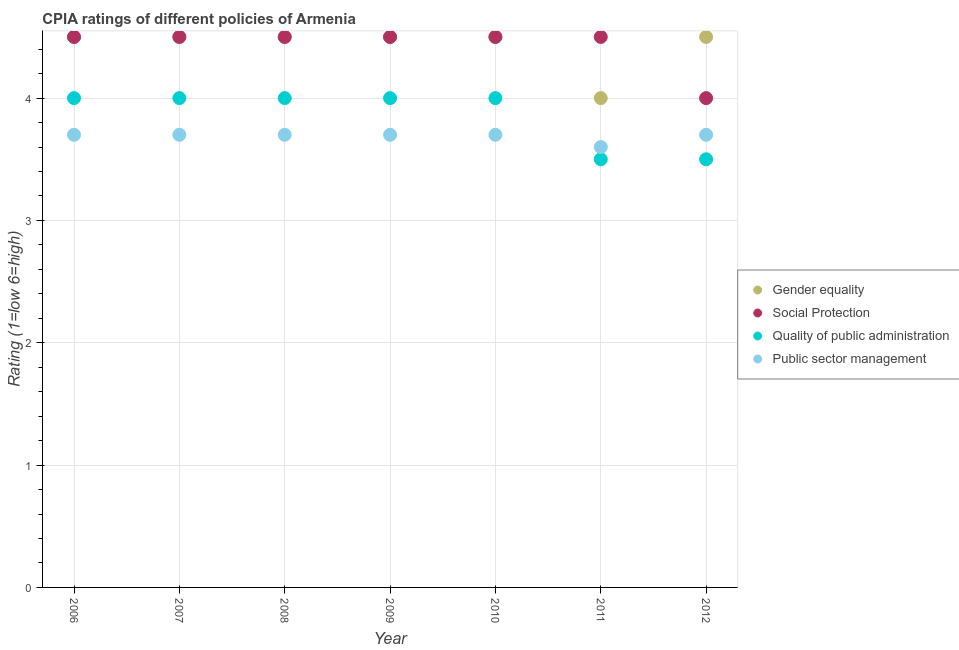Is the number of dotlines equal to the number of legend labels?
Make the answer very short. Yes. What is the cpia rating of gender equality in 2010?
Give a very brief answer. 4.5. In which year was the cpia rating of gender equality maximum?
Your answer should be very brief. 2006. In which year was the cpia rating of gender equality minimum?
Make the answer very short. 2011. What is the difference between the cpia rating of quality of public administration in 2010 and that in 2012?
Offer a terse response. 0.5. What is the difference between the cpia rating of public sector management in 2007 and the cpia rating of social protection in 2009?
Provide a succinct answer. -0.8. What is the average cpia rating of social protection per year?
Give a very brief answer. 4.43. In the year 2012, what is the difference between the cpia rating of quality of public administration and cpia rating of public sector management?
Your response must be concise. -0.2. In how many years, is the cpia rating of quality of public administration greater than 1.6?
Offer a very short reply. 7. Is the difference between the cpia rating of gender equality in 2006 and 2009 greater than the difference between the cpia rating of quality of public administration in 2006 and 2009?
Your answer should be very brief. No. What is the difference between the highest and the second highest cpia rating of social protection?
Your answer should be very brief. 0. What is the difference between the highest and the lowest cpia rating of gender equality?
Ensure brevity in your answer.  0.5. Is the sum of the cpia rating of public sector management in 2007 and 2012 greater than the maximum cpia rating of gender equality across all years?
Offer a terse response. Yes. Is it the case that in every year, the sum of the cpia rating of gender equality and cpia rating of social protection is greater than the cpia rating of quality of public administration?
Provide a succinct answer. Yes. Does the cpia rating of public sector management monotonically increase over the years?
Make the answer very short. No. Is the cpia rating of gender equality strictly greater than the cpia rating of public sector management over the years?
Provide a short and direct response. Yes. Is the cpia rating of public sector management strictly less than the cpia rating of gender equality over the years?
Provide a short and direct response. Yes. How many dotlines are there?
Keep it short and to the point. 4. What is the difference between two consecutive major ticks on the Y-axis?
Offer a very short reply. 1. Are the values on the major ticks of Y-axis written in scientific E-notation?
Provide a succinct answer. No. Does the graph contain any zero values?
Provide a succinct answer. No. Where does the legend appear in the graph?
Your answer should be compact. Center right. How many legend labels are there?
Ensure brevity in your answer.  4. How are the legend labels stacked?
Keep it short and to the point. Vertical. What is the title of the graph?
Your answer should be compact. CPIA ratings of different policies of Armenia. What is the label or title of the X-axis?
Offer a very short reply. Year. What is the label or title of the Y-axis?
Make the answer very short. Rating (1=low 6=high). What is the Rating (1=low 6=high) in Gender equality in 2006?
Ensure brevity in your answer.  4.5. What is the Rating (1=low 6=high) in Social Protection in 2006?
Provide a short and direct response. 4.5. What is the Rating (1=low 6=high) in Quality of public administration in 2006?
Keep it short and to the point. 4. What is the Rating (1=low 6=high) in Public sector management in 2006?
Provide a succinct answer. 3.7. What is the Rating (1=low 6=high) of Public sector management in 2007?
Provide a succinct answer. 3.7. What is the Rating (1=low 6=high) in Social Protection in 2008?
Your response must be concise. 4.5. What is the Rating (1=low 6=high) in Quality of public administration in 2008?
Your response must be concise. 4. What is the Rating (1=low 6=high) in Quality of public administration in 2009?
Your answer should be very brief. 4. What is the Rating (1=low 6=high) of Public sector management in 2009?
Provide a short and direct response. 3.7. What is the Rating (1=low 6=high) in Social Protection in 2010?
Offer a very short reply. 4.5. What is the Rating (1=low 6=high) of Gender equality in 2011?
Your response must be concise. 4. What is the Rating (1=low 6=high) of Quality of public administration in 2011?
Give a very brief answer. 3.5. What is the Rating (1=low 6=high) of Public sector management in 2011?
Offer a terse response. 3.6. What is the Rating (1=low 6=high) of Gender equality in 2012?
Give a very brief answer. 4.5. What is the Rating (1=low 6=high) in Social Protection in 2012?
Ensure brevity in your answer.  4. What is the Rating (1=low 6=high) in Public sector management in 2012?
Offer a terse response. 3.7. Across all years, what is the maximum Rating (1=low 6=high) of Quality of public administration?
Offer a very short reply. 4. Across all years, what is the minimum Rating (1=low 6=high) of Gender equality?
Provide a succinct answer. 4. Across all years, what is the minimum Rating (1=low 6=high) in Quality of public administration?
Your answer should be compact. 3.5. What is the total Rating (1=low 6=high) of Quality of public administration in the graph?
Your answer should be very brief. 27. What is the total Rating (1=low 6=high) of Public sector management in the graph?
Offer a terse response. 25.8. What is the difference between the Rating (1=low 6=high) in Gender equality in 2006 and that in 2007?
Make the answer very short. 0. What is the difference between the Rating (1=low 6=high) of Social Protection in 2006 and that in 2007?
Make the answer very short. 0. What is the difference between the Rating (1=low 6=high) in Public sector management in 2006 and that in 2007?
Make the answer very short. 0. What is the difference between the Rating (1=low 6=high) of Gender equality in 2006 and that in 2008?
Ensure brevity in your answer.  0. What is the difference between the Rating (1=low 6=high) of Quality of public administration in 2006 and that in 2008?
Ensure brevity in your answer.  0. What is the difference between the Rating (1=low 6=high) of Public sector management in 2006 and that in 2008?
Provide a short and direct response. 0. What is the difference between the Rating (1=low 6=high) in Public sector management in 2006 and that in 2009?
Ensure brevity in your answer.  0. What is the difference between the Rating (1=low 6=high) of Gender equality in 2006 and that in 2010?
Your response must be concise. 0. What is the difference between the Rating (1=low 6=high) of Social Protection in 2006 and that in 2010?
Provide a succinct answer. 0. What is the difference between the Rating (1=low 6=high) in Public sector management in 2006 and that in 2010?
Give a very brief answer. 0. What is the difference between the Rating (1=low 6=high) in Social Protection in 2006 and that in 2011?
Make the answer very short. 0. What is the difference between the Rating (1=low 6=high) in Quality of public administration in 2006 and that in 2011?
Offer a terse response. 0.5. What is the difference between the Rating (1=low 6=high) of Public sector management in 2006 and that in 2011?
Provide a succinct answer. 0.1. What is the difference between the Rating (1=low 6=high) in Social Protection in 2006 and that in 2012?
Your answer should be very brief. 0.5. What is the difference between the Rating (1=low 6=high) of Quality of public administration in 2006 and that in 2012?
Your answer should be compact. 0.5. What is the difference between the Rating (1=low 6=high) in Social Protection in 2007 and that in 2008?
Your answer should be compact. 0. What is the difference between the Rating (1=low 6=high) in Public sector management in 2007 and that in 2008?
Make the answer very short. 0. What is the difference between the Rating (1=low 6=high) in Gender equality in 2007 and that in 2009?
Your answer should be very brief. 0. What is the difference between the Rating (1=low 6=high) in Public sector management in 2007 and that in 2009?
Your answer should be compact. 0. What is the difference between the Rating (1=low 6=high) in Public sector management in 2007 and that in 2010?
Your answer should be compact. 0. What is the difference between the Rating (1=low 6=high) in Social Protection in 2007 and that in 2011?
Keep it short and to the point. 0. What is the difference between the Rating (1=low 6=high) of Public sector management in 2007 and that in 2011?
Your answer should be very brief. 0.1. What is the difference between the Rating (1=low 6=high) in Social Protection in 2007 and that in 2012?
Your answer should be compact. 0.5. What is the difference between the Rating (1=low 6=high) in Public sector management in 2007 and that in 2012?
Provide a succinct answer. 0. What is the difference between the Rating (1=low 6=high) in Quality of public administration in 2008 and that in 2009?
Offer a very short reply. 0. What is the difference between the Rating (1=low 6=high) of Public sector management in 2008 and that in 2009?
Ensure brevity in your answer.  0. What is the difference between the Rating (1=low 6=high) of Gender equality in 2008 and that in 2011?
Offer a very short reply. 0.5. What is the difference between the Rating (1=low 6=high) in Quality of public administration in 2008 and that in 2011?
Provide a succinct answer. 0.5. What is the difference between the Rating (1=low 6=high) in Gender equality in 2008 and that in 2012?
Your answer should be compact. 0. What is the difference between the Rating (1=low 6=high) in Social Protection in 2008 and that in 2012?
Your answer should be very brief. 0.5. What is the difference between the Rating (1=low 6=high) of Public sector management in 2008 and that in 2012?
Your answer should be very brief. 0. What is the difference between the Rating (1=low 6=high) in Gender equality in 2009 and that in 2010?
Provide a succinct answer. 0. What is the difference between the Rating (1=low 6=high) of Public sector management in 2009 and that in 2010?
Give a very brief answer. 0. What is the difference between the Rating (1=low 6=high) in Gender equality in 2009 and that in 2011?
Keep it short and to the point. 0.5. What is the difference between the Rating (1=low 6=high) in Public sector management in 2009 and that in 2011?
Offer a terse response. 0.1. What is the difference between the Rating (1=low 6=high) of Quality of public administration in 2010 and that in 2011?
Keep it short and to the point. 0.5. What is the difference between the Rating (1=low 6=high) of Social Protection in 2010 and that in 2012?
Your response must be concise. 0.5. What is the difference between the Rating (1=low 6=high) in Social Protection in 2011 and that in 2012?
Your answer should be compact. 0.5. What is the difference between the Rating (1=low 6=high) in Public sector management in 2011 and that in 2012?
Provide a succinct answer. -0.1. What is the difference between the Rating (1=low 6=high) in Social Protection in 2006 and the Rating (1=low 6=high) in Public sector management in 2007?
Give a very brief answer. 0.8. What is the difference between the Rating (1=low 6=high) of Gender equality in 2006 and the Rating (1=low 6=high) of Social Protection in 2008?
Give a very brief answer. 0. What is the difference between the Rating (1=low 6=high) of Gender equality in 2006 and the Rating (1=low 6=high) of Public sector management in 2008?
Offer a terse response. 0.8. What is the difference between the Rating (1=low 6=high) of Social Protection in 2006 and the Rating (1=low 6=high) of Quality of public administration in 2008?
Keep it short and to the point. 0.5. What is the difference between the Rating (1=low 6=high) in Gender equality in 2006 and the Rating (1=low 6=high) in Quality of public administration in 2010?
Your answer should be compact. 0.5. What is the difference between the Rating (1=low 6=high) of Gender equality in 2006 and the Rating (1=low 6=high) of Public sector management in 2011?
Your answer should be very brief. 0.9. What is the difference between the Rating (1=low 6=high) of Social Protection in 2006 and the Rating (1=low 6=high) of Public sector management in 2011?
Ensure brevity in your answer.  0.9. What is the difference between the Rating (1=low 6=high) in Gender equality in 2006 and the Rating (1=low 6=high) in Public sector management in 2012?
Provide a succinct answer. 0.8. What is the difference between the Rating (1=low 6=high) of Social Protection in 2006 and the Rating (1=low 6=high) of Public sector management in 2012?
Your response must be concise. 0.8. What is the difference between the Rating (1=low 6=high) in Gender equality in 2007 and the Rating (1=low 6=high) in Quality of public administration in 2008?
Offer a very short reply. 0.5. What is the difference between the Rating (1=low 6=high) in Gender equality in 2007 and the Rating (1=low 6=high) in Public sector management in 2008?
Your answer should be very brief. 0.8. What is the difference between the Rating (1=low 6=high) of Social Protection in 2007 and the Rating (1=low 6=high) of Public sector management in 2008?
Offer a terse response. 0.8. What is the difference between the Rating (1=low 6=high) in Gender equality in 2007 and the Rating (1=low 6=high) in Social Protection in 2009?
Offer a very short reply. 0. What is the difference between the Rating (1=low 6=high) in Gender equality in 2007 and the Rating (1=low 6=high) in Quality of public administration in 2009?
Your response must be concise. 0.5. What is the difference between the Rating (1=low 6=high) in Gender equality in 2007 and the Rating (1=low 6=high) in Public sector management in 2009?
Ensure brevity in your answer.  0.8. What is the difference between the Rating (1=low 6=high) in Social Protection in 2007 and the Rating (1=low 6=high) in Quality of public administration in 2009?
Provide a succinct answer. 0.5. What is the difference between the Rating (1=low 6=high) of Gender equality in 2007 and the Rating (1=low 6=high) of Social Protection in 2010?
Your answer should be very brief. 0. What is the difference between the Rating (1=low 6=high) of Gender equality in 2007 and the Rating (1=low 6=high) of Quality of public administration in 2010?
Your answer should be compact. 0.5. What is the difference between the Rating (1=low 6=high) in Social Protection in 2007 and the Rating (1=low 6=high) in Quality of public administration in 2010?
Provide a succinct answer. 0.5. What is the difference between the Rating (1=low 6=high) in Social Protection in 2007 and the Rating (1=low 6=high) in Public sector management in 2010?
Your answer should be compact. 0.8. What is the difference between the Rating (1=low 6=high) of Gender equality in 2007 and the Rating (1=low 6=high) of Social Protection in 2011?
Keep it short and to the point. 0. What is the difference between the Rating (1=low 6=high) in Gender equality in 2007 and the Rating (1=low 6=high) in Quality of public administration in 2011?
Your answer should be compact. 1. What is the difference between the Rating (1=low 6=high) of Social Protection in 2007 and the Rating (1=low 6=high) of Quality of public administration in 2011?
Make the answer very short. 1. What is the difference between the Rating (1=low 6=high) in Social Protection in 2007 and the Rating (1=low 6=high) in Public sector management in 2011?
Ensure brevity in your answer.  0.9. What is the difference between the Rating (1=low 6=high) of Quality of public administration in 2007 and the Rating (1=low 6=high) of Public sector management in 2011?
Keep it short and to the point. 0.4. What is the difference between the Rating (1=low 6=high) of Social Protection in 2007 and the Rating (1=low 6=high) of Public sector management in 2012?
Provide a succinct answer. 0.8. What is the difference between the Rating (1=low 6=high) of Gender equality in 2008 and the Rating (1=low 6=high) of Social Protection in 2009?
Make the answer very short. 0. What is the difference between the Rating (1=low 6=high) in Social Protection in 2008 and the Rating (1=low 6=high) in Quality of public administration in 2009?
Provide a succinct answer. 0.5. What is the difference between the Rating (1=low 6=high) of Social Protection in 2008 and the Rating (1=low 6=high) of Public sector management in 2009?
Your response must be concise. 0.8. What is the difference between the Rating (1=low 6=high) in Gender equality in 2008 and the Rating (1=low 6=high) in Quality of public administration in 2010?
Provide a short and direct response. 0.5. What is the difference between the Rating (1=low 6=high) in Social Protection in 2008 and the Rating (1=low 6=high) in Quality of public administration in 2010?
Keep it short and to the point. 0.5. What is the difference between the Rating (1=low 6=high) of Social Protection in 2008 and the Rating (1=low 6=high) of Public sector management in 2010?
Your answer should be very brief. 0.8. What is the difference between the Rating (1=low 6=high) of Gender equality in 2008 and the Rating (1=low 6=high) of Social Protection in 2011?
Provide a short and direct response. 0. What is the difference between the Rating (1=low 6=high) in Social Protection in 2008 and the Rating (1=low 6=high) in Quality of public administration in 2011?
Keep it short and to the point. 1. What is the difference between the Rating (1=low 6=high) in Social Protection in 2008 and the Rating (1=low 6=high) in Public sector management in 2011?
Your answer should be compact. 0.9. What is the difference between the Rating (1=low 6=high) of Gender equality in 2008 and the Rating (1=low 6=high) of Public sector management in 2012?
Your response must be concise. 0.8. What is the difference between the Rating (1=low 6=high) of Quality of public administration in 2008 and the Rating (1=low 6=high) of Public sector management in 2012?
Keep it short and to the point. 0.3. What is the difference between the Rating (1=low 6=high) of Gender equality in 2009 and the Rating (1=low 6=high) of Quality of public administration in 2010?
Offer a very short reply. 0.5. What is the difference between the Rating (1=low 6=high) in Gender equality in 2009 and the Rating (1=low 6=high) in Public sector management in 2010?
Give a very brief answer. 0.8. What is the difference between the Rating (1=low 6=high) in Social Protection in 2009 and the Rating (1=low 6=high) in Public sector management in 2010?
Give a very brief answer. 0.8. What is the difference between the Rating (1=low 6=high) in Quality of public administration in 2009 and the Rating (1=low 6=high) in Public sector management in 2010?
Keep it short and to the point. 0.3. What is the difference between the Rating (1=low 6=high) in Gender equality in 2009 and the Rating (1=low 6=high) in Social Protection in 2011?
Provide a succinct answer. 0. What is the difference between the Rating (1=low 6=high) of Gender equality in 2009 and the Rating (1=low 6=high) of Public sector management in 2011?
Give a very brief answer. 0.9. What is the difference between the Rating (1=low 6=high) in Gender equality in 2009 and the Rating (1=low 6=high) in Quality of public administration in 2012?
Offer a terse response. 1. What is the difference between the Rating (1=low 6=high) in Social Protection in 2009 and the Rating (1=low 6=high) in Public sector management in 2012?
Your response must be concise. 0.8. What is the difference between the Rating (1=low 6=high) of Gender equality in 2010 and the Rating (1=low 6=high) of Quality of public administration in 2011?
Make the answer very short. 1. What is the difference between the Rating (1=low 6=high) in Gender equality in 2010 and the Rating (1=low 6=high) in Public sector management in 2011?
Offer a terse response. 0.9. What is the difference between the Rating (1=low 6=high) of Social Protection in 2010 and the Rating (1=low 6=high) of Public sector management in 2011?
Give a very brief answer. 0.9. What is the difference between the Rating (1=low 6=high) of Quality of public administration in 2010 and the Rating (1=low 6=high) of Public sector management in 2011?
Offer a terse response. 0.4. What is the difference between the Rating (1=low 6=high) in Gender equality in 2010 and the Rating (1=low 6=high) in Social Protection in 2012?
Your answer should be compact. 0.5. What is the difference between the Rating (1=low 6=high) of Gender equality in 2010 and the Rating (1=low 6=high) of Quality of public administration in 2012?
Your response must be concise. 1. What is the difference between the Rating (1=low 6=high) of Quality of public administration in 2010 and the Rating (1=low 6=high) of Public sector management in 2012?
Your answer should be very brief. 0.3. What is the difference between the Rating (1=low 6=high) of Gender equality in 2011 and the Rating (1=low 6=high) of Social Protection in 2012?
Offer a terse response. 0. What is the difference between the Rating (1=low 6=high) of Quality of public administration in 2011 and the Rating (1=low 6=high) of Public sector management in 2012?
Your answer should be very brief. -0.2. What is the average Rating (1=low 6=high) of Gender equality per year?
Keep it short and to the point. 4.43. What is the average Rating (1=low 6=high) of Social Protection per year?
Offer a very short reply. 4.43. What is the average Rating (1=low 6=high) in Quality of public administration per year?
Keep it short and to the point. 3.86. What is the average Rating (1=low 6=high) of Public sector management per year?
Offer a terse response. 3.69. In the year 2006, what is the difference between the Rating (1=low 6=high) in Gender equality and Rating (1=low 6=high) in Quality of public administration?
Offer a very short reply. 0.5. In the year 2006, what is the difference between the Rating (1=low 6=high) in Gender equality and Rating (1=low 6=high) in Public sector management?
Provide a succinct answer. 0.8. In the year 2006, what is the difference between the Rating (1=low 6=high) in Social Protection and Rating (1=low 6=high) in Public sector management?
Give a very brief answer. 0.8. In the year 2006, what is the difference between the Rating (1=low 6=high) in Quality of public administration and Rating (1=low 6=high) in Public sector management?
Give a very brief answer. 0.3. In the year 2007, what is the difference between the Rating (1=low 6=high) of Gender equality and Rating (1=low 6=high) of Social Protection?
Your answer should be compact. 0. In the year 2007, what is the difference between the Rating (1=low 6=high) in Social Protection and Rating (1=low 6=high) in Quality of public administration?
Provide a short and direct response. 0.5. In the year 2008, what is the difference between the Rating (1=low 6=high) in Gender equality and Rating (1=low 6=high) in Quality of public administration?
Give a very brief answer. 0.5. In the year 2008, what is the difference between the Rating (1=low 6=high) of Gender equality and Rating (1=low 6=high) of Public sector management?
Offer a very short reply. 0.8. In the year 2008, what is the difference between the Rating (1=low 6=high) in Quality of public administration and Rating (1=low 6=high) in Public sector management?
Your answer should be compact. 0.3. In the year 2009, what is the difference between the Rating (1=low 6=high) of Gender equality and Rating (1=low 6=high) of Quality of public administration?
Make the answer very short. 0.5. In the year 2009, what is the difference between the Rating (1=low 6=high) of Gender equality and Rating (1=low 6=high) of Public sector management?
Offer a very short reply. 0.8. In the year 2009, what is the difference between the Rating (1=low 6=high) of Social Protection and Rating (1=low 6=high) of Quality of public administration?
Ensure brevity in your answer.  0.5. In the year 2010, what is the difference between the Rating (1=low 6=high) of Social Protection and Rating (1=low 6=high) of Quality of public administration?
Provide a succinct answer. 0.5. In the year 2010, what is the difference between the Rating (1=low 6=high) in Quality of public administration and Rating (1=low 6=high) in Public sector management?
Provide a short and direct response. 0.3. In the year 2011, what is the difference between the Rating (1=low 6=high) in Gender equality and Rating (1=low 6=high) in Quality of public administration?
Provide a succinct answer. 0.5. In the year 2011, what is the difference between the Rating (1=low 6=high) in Social Protection and Rating (1=low 6=high) in Quality of public administration?
Your answer should be compact. 1. In the year 2011, what is the difference between the Rating (1=low 6=high) in Quality of public administration and Rating (1=low 6=high) in Public sector management?
Give a very brief answer. -0.1. In the year 2012, what is the difference between the Rating (1=low 6=high) in Gender equality and Rating (1=low 6=high) in Public sector management?
Your response must be concise. 0.8. In the year 2012, what is the difference between the Rating (1=low 6=high) in Social Protection and Rating (1=low 6=high) in Quality of public administration?
Your response must be concise. 0.5. In the year 2012, what is the difference between the Rating (1=low 6=high) in Quality of public administration and Rating (1=low 6=high) in Public sector management?
Keep it short and to the point. -0.2. What is the ratio of the Rating (1=low 6=high) in Gender equality in 2006 to that in 2007?
Your response must be concise. 1. What is the ratio of the Rating (1=low 6=high) in Quality of public administration in 2006 to that in 2007?
Make the answer very short. 1. What is the ratio of the Rating (1=low 6=high) in Social Protection in 2006 to that in 2008?
Keep it short and to the point. 1. What is the ratio of the Rating (1=low 6=high) in Public sector management in 2006 to that in 2008?
Provide a short and direct response. 1. What is the ratio of the Rating (1=low 6=high) of Gender equality in 2006 to that in 2009?
Give a very brief answer. 1. What is the ratio of the Rating (1=low 6=high) in Social Protection in 2006 to that in 2009?
Your response must be concise. 1. What is the ratio of the Rating (1=low 6=high) of Social Protection in 2006 to that in 2010?
Make the answer very short. 1. What is the ratio of the Rating (1=low 6=high) in Quality of public administration in 2006 to that in 2010?
Provide a succinct answer. 1. What is the ratio of the Rating (1=low 6=high) in Public sector management in 2006 to that in 2010?
Offer a very short reply. 1. What is the ratio of the Rating (1=low 6=high) of Gender equality in 2006 to that in 2011?
Your response must be concise. 1.12. What is the ratio of the Rating (1=low 6=high) of Social Protection in 2006 to that in 2011?
Provide a short and direct response. 1. What is the ratio of the Rating (1=low 6=high) in Public sector management in 2006 to that in 2011?
Your answer should be very brief. 1.03. What is the ratio of the Rating (1=low 6=high) in Public sector management in 2006 to that in 2012?
Your answer should be very brief. 1. What is the ratio of the Rating (1=low 6=high) of Gender equality in 2007 to that in 2008?
Keep it short and to the point. 1. What is the ratio of the Rating (1=low 6=high) of Quality of public administration in 2007 to that in 2008?
Offer a terse response. 1. What is the ratio of the Rating (1=low 6=high) of Social Protection in 2007 to that in 2009?
Provide a succinct answer. 1. What is the ratio of the Rating (1=low 6=high) of Quality of public administration in 2007 to that in 2009?
Offer a terse response. 1. What is the ratio of the Rating (1=low 6=high) of Quality of public administration in 2007 to that in 2010?
Give a very brief answer. 1. What is the ratio of the Rating (1=low 6=high) in Public sector management in 2007 to that in 2010?
Offer a very short reply. 1. What is the ratio of the Rating (1=low 6=high) of Quality of public administration in 2007 to that in 2011?
Offer a terse response. 1.14. What is the ratio of the Rating (1=low 6=high) of Public sector management in 2007 to that in 2011?
Offer a terse response. 1.03. What is the ratio of the Rating (1=low 6=high) in Gender equality in 2007 to that in 2012?
Make the answer very short. 1. What is the ratio of the Rating (1=low 6=high) of Public sector management in 2007 to that in 2012?
Make the answer very short. 1. What is the ratio of the Rating (1=low 6=high) of Gender equality in 2008 to that in 2009?
Your answer should be very brief. 1. What is the ratio of the Rating (1=low 6=high) of Social Protection in 2008 to that in 2009?
Your answer should be compact. 1. What is the ratio of the Rating (1=low 6=high) of Quality of public administration in 2008 to that in 2009?
Your answer should be very brief. 1. What is the ratio of the Rating (1=low 6=high) of Social Protection in 2008 to that in 2010?
Give a very brief answer. 1. What is the ratio of the Rating (1=low 6=high) of Public sector management in 2008 to that in 2010?
Make the answer very short. 1. What is the ratio of the Rating (1=low 6=high) in Social Protection in 2008 to that in 2011?
Ensure brevity in your answer.  1. What is the ratio of the Rating (1=low 6=high) of Quality of public administration in 2008 to that in 2011?
Provide a succinct answer. 1.14. What is the ratio of the Rating (1=low 6=high) of Public sector management in 2008 to that in 2011?
Make the answer very short. 1.03. What is the ratio of the Rating (1=low 6=high) of Gender equality in 2008 to that in 2012?
Offer a terse response. 1. What is the ratio of the Rating (1=low 6=high) of Quality of public administration in 2008 to that in 2012?
Your response must be concise. 1.14. What is the ratio of the Rating (1=low 6=high) in Social Protection in 2009 to that in 2010?
Keep it short and to the point. 1. What is the ratio of the Rating (1=low 6=high) of Quality of public administration in 2009 to that in 2010?
Offer a terse response. 1. What is the ratio of the Rating (1=low 6=high) of Public sector management in 2009 to that in 2010?
Make the answer very short. 1. What is the ratio of the Rating (1=low 6=high) in Social Protection in 2009 to that in 2011?
Your answer should be very brief. 1. What is the ratio of the Rating (1=low 6=high) of Public sector management in 2009 to that in 2011?
Give a very brief answer. 1.03. What is the ratio of the Rating (1=low 6=high) of Social Protection in 2010 to that in 2011?
Offer a very short reply. 1. What is the ratio of the Rating (1=low 6=high) in Quality of public administration in 2010 to that in 2011?
Make the answer very short. 1.14. What is the ratio of the Rating (1=low 6=high) of Public sector management in 2010 to that in 2011?
Keep it short and to the point. 1.03. What is the ratio of the Rating (1=low 6=high) of Gender equality in 2010 to that in 2012?
Provide a short and direct response. 1. What is the ratio of the Rating (1=low 6=high) of Public sector management in 2010 to that in 2012?
Provide a succinct answer. 1. What is the ratio of the Rating (1=low 6=high) in Quality of public administration in 2011 to that in 2012?
Keep it short and to the point. 1. What is the difference between the highest and the second highest Rating (1=low 6=high) in Gender equality?
Your answer should be very brief. 0. What is the difference between the highest and the second highest Rating (1=low 6=high) of Social Protection?
Offer a terse response. 0. What is the difference between the highest and the lowest Rating (1=low 6=high) of Social Protection?
Your answer should be very brief. 0.5. What is the difference between the highest and the lowest Rating (1=low 6=high) in Quality of public administration?
Your answer should be compact. 0.5. What is the difference between the highest and the lowest Rating (1=low 6=high) in Public sector management?
Make the answer very short. 0.1. 